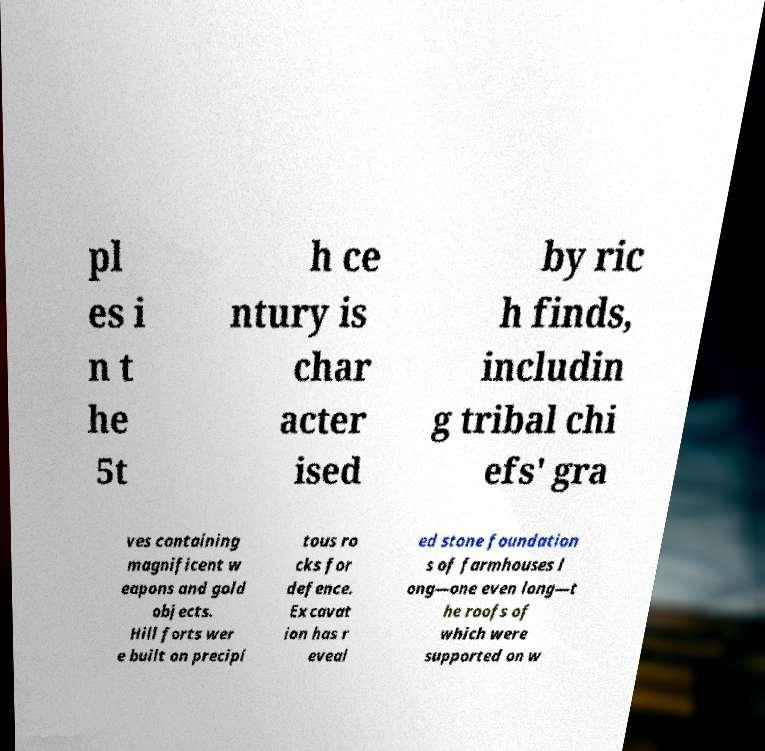Could you extract and type out the text from this image? pl es i n t he 5t h ce ntury is char acter ised by ric h finds, includin g tribal chi efs' gra ves containing magnificent w eapons and gold objects. Hill forts wer e built on precipi tous ro cks for defence. Excavat ion has r eveal ed stone foundation s of farmhouses l ong—one even long—t he roofs of which were supported on w 